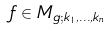Convert formula to latex. <formula><loc_0><loc_0><loc_500><loc_500>f \in M _ { g ; k _ { 1 } , \dots , k _ { n } }</formula> 